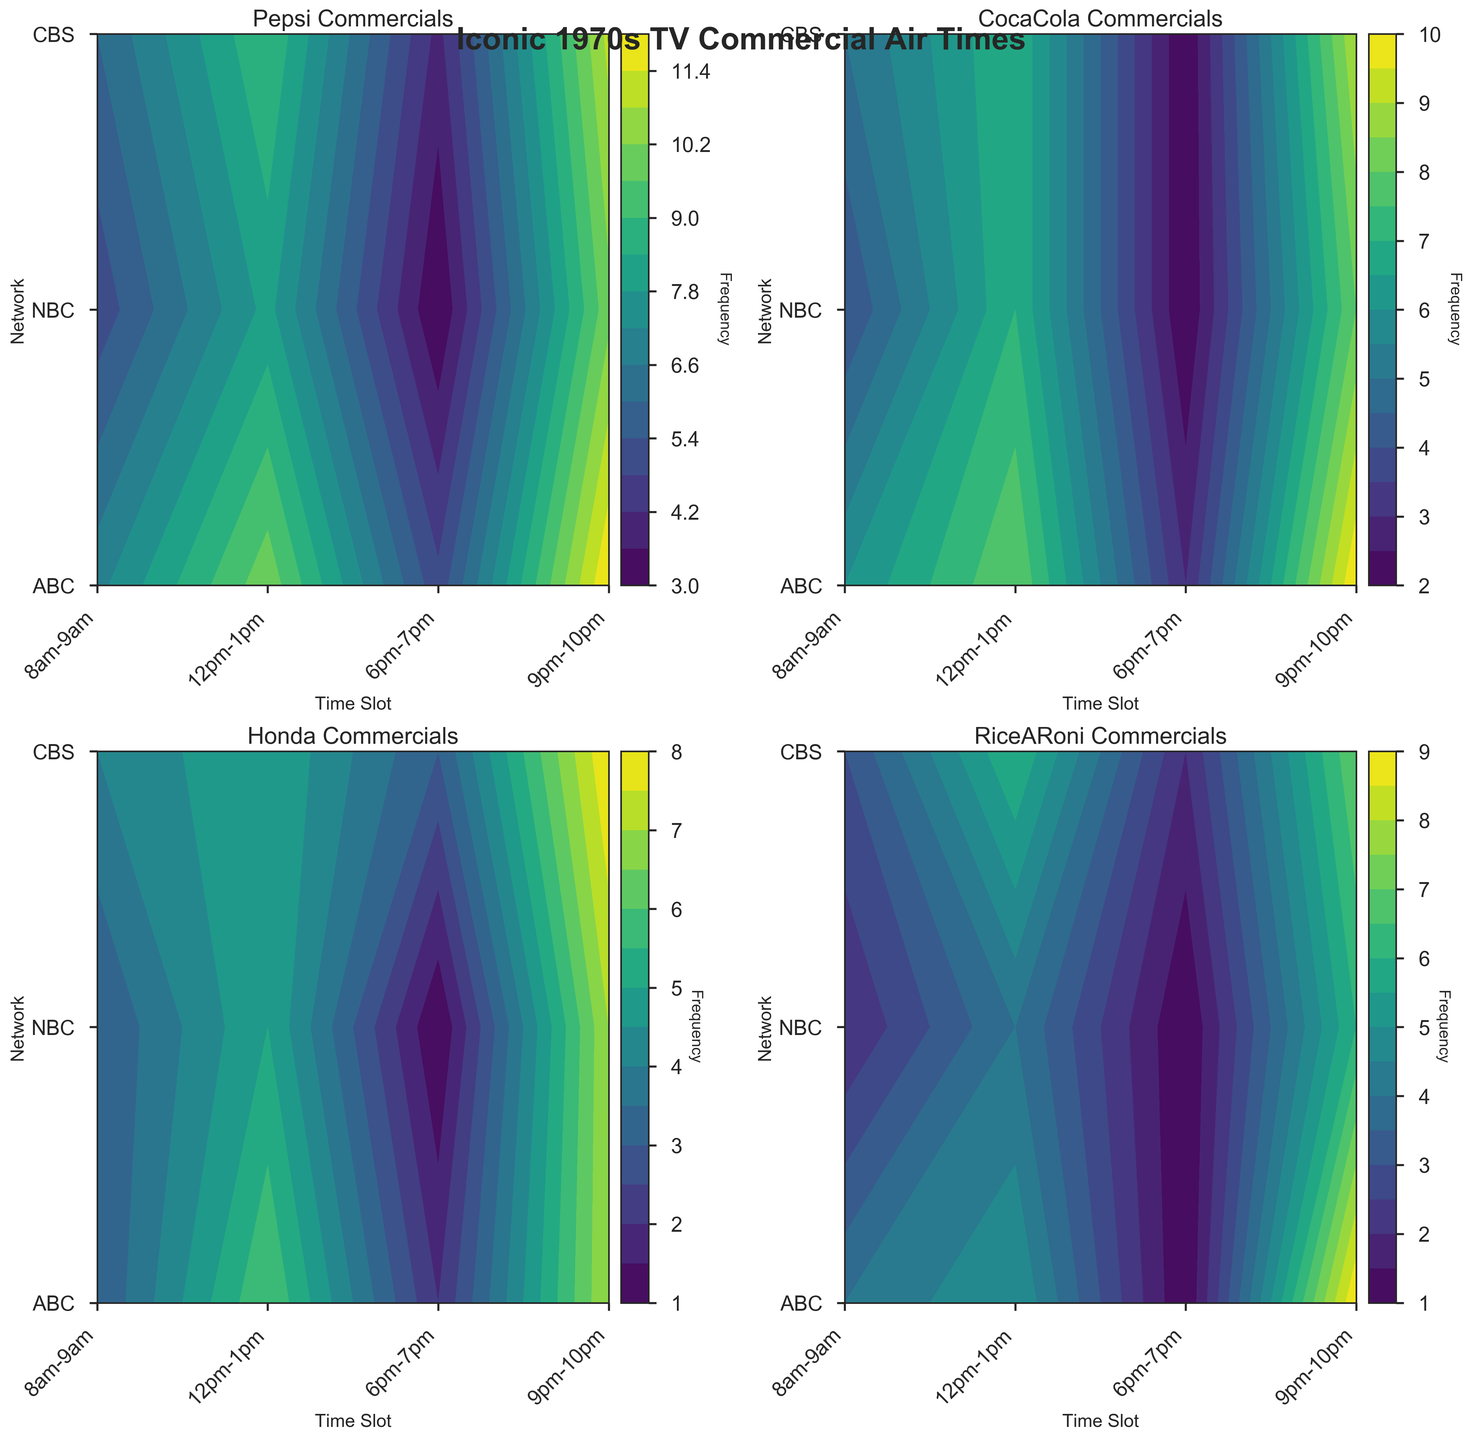What is the title of the entire figure? The title is located at the top of the figure and reads "Iconic 1970s TV Commercial Air Times."
Answer: "Iconic 1970s TV Commercial Air Times" Which time slot on CBS has the highest frequency of 1970_CocaCola commercials? By looking at the "1970_CocaCola Commercials" plot for CBS, we see that the highest frequency occurs in the 6pm-7pm time slot.
Answer: 6pm-7pm Comparing ABC and NBC, during which time slot do both networks have the least frequency of 1970_Pepsi commercials? By checking the "1970_Pepsi Commercials" plots for both ABC and NBC, the least frequency for each network is at 8am-9am, where ABC has 5 and NBC has 4 commercials.
Answer: 8am-9am In the 12pm-1pm time slot, which commercial has the highest frequency on any network? We need to check the contour levels for the 12pm-1pm time slot across all plots. The highest frequency value among them is ABC's 1970_CocaCola commercials with a frequency of 6.
Answer: 1970_CocaCola on ABC What is the average frequency of 1970_RiceARoni commercials aired on NBC across all time slots? Summing up the values for NBC in the "1970_RiceARoni Commercials" plot: 2+3+6+7 = 18, then dividing by the number of time slots (4), we get 18/4 = 4.5.
Answer: 4.5 Which network has the most variable frequency of 1970_Honda commercials? By comparing the frequency ranges in the "1970_Honda Commercials" plot for all networks, NBC has values ranging from 3 to 8 (variability of 5), which is the most variable.
Answer: NBC How does the frequency of 1970_Pepsi commercials on CBS at 9pm-10pm compare to the same time slot on NBC? By observing the "1970_Pepsi Commercials" plot, CBS has a frequency of 10 and NBC has a frequency of 11 for the 9pm-10pm time slot. NBC is higher.
Answer: NBC is higher Is there any network where the 8am-9am time slot does not have the least frequency for any of the commercials? By examining all plots, every network has at least one commercial with a lesser frequency or tied for the least frequency at 8am-9am.
Answer: No How does the frequency of 1970_CocaCola commercials at 6pm-7pm on ABC compare to the frequency of 1970_Honda commercials at the same time and network? For the 6pm-7pm slot on ABC, the "1970_CocaCola Commercials" plot shows a frequency of 8 and the "1970_Honda Commercials" plot shows a frequency of 6.
Answer: CocaCola is higher 